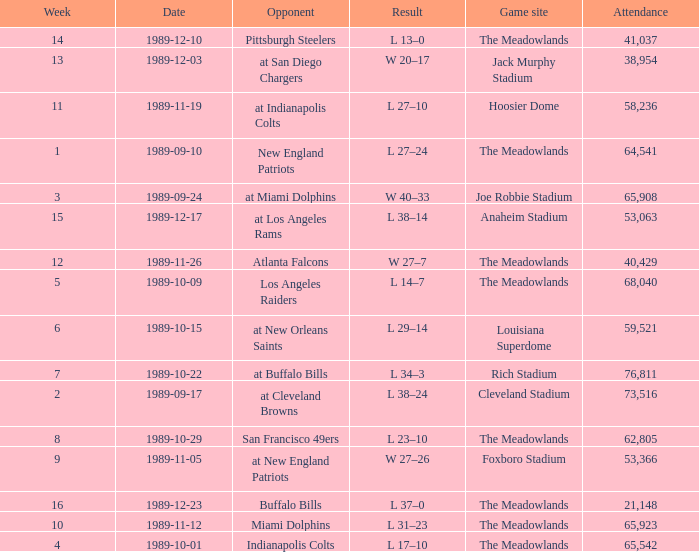What day did they play before week 2? 1989-09-10. Could you help me parse every detail presented in this table? {'header': ['Week', 'Date', 'Opponent', 'Result', 'Game site', 'Attendance'], 'rows': [['14', '1989-12-10', 'Pittsburgh Steelers', 'L 13–0', 'The Meadowlands', '41,037'], ['13', '1989-12-03', 'at San Diego Chargers', 'W 20–17', 'Jack Murphy Stadium', '38,954'], ['11', '1989-11-19', 'at Indianapolis Colts', 'L 27–10', 'Hoosier Dome', '58,236'], ['1', '1989-09-10', 'New England Patriots', 'L 27–24', 'The Meadowlands', '64,541'], ['3', '1989-09-24', 'at Miami Dolphins', 'W 40–33', 'Joe Robbie Stadium', '65,908'], ['15', '1989-12-17', 'at Los Angeles Rams', 'L 38–14', 'Anaheim Stadium', '53,063'], ['12', '1989-11-26', 'Atlanta Falcons', 'W 27–7', 'The Meadowlands', '40,429'], ['5', '1989-10-09', 'Los Angeles Raiders', 'L 14–7', 'The Meadowlands', '68,040'], ['6', '1989-10-15', 'at New Orleans Saints', 'L 29–14', 'Louisiana Superdome', '59,521'], ['7', '1989-10-22', 'at Buffalo Bills', 'L 34–3', 'Rich Stadium', '76,811'], ['2', '1989-09-17', 'at Cleveland Browns', 'L 38–24', 'Cleveland Stadium', '73,516'], ['8', '1989-10-29', 'San Francisco 49ers', 'L 23–10', 'The Meadowlands', '62,805'], ['9', '1989-11-05', 'at New England Patriots', 'W 27–26', 'Foxboro Stadium', '53,366'], ['16', '1989-12-23', 'Buffalo Bills', 'L 37–0', 'The Meadowlands', '21,148'], ['10', '1989-11-12', 'Miami Dolphins', 'L 31–23', 'The Meadowlands', '65,923'], ['4', '1989-10-01', 'Indianapolis Colts', 'L 17–10', 'The Meadowlands', '65,542']]} 